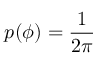Convert formula to latex. <formula><loc_0><loc_0><loc_500><loc_500>p ( \phi ) = \frac { 1 } { 2 \pi }</formula> 